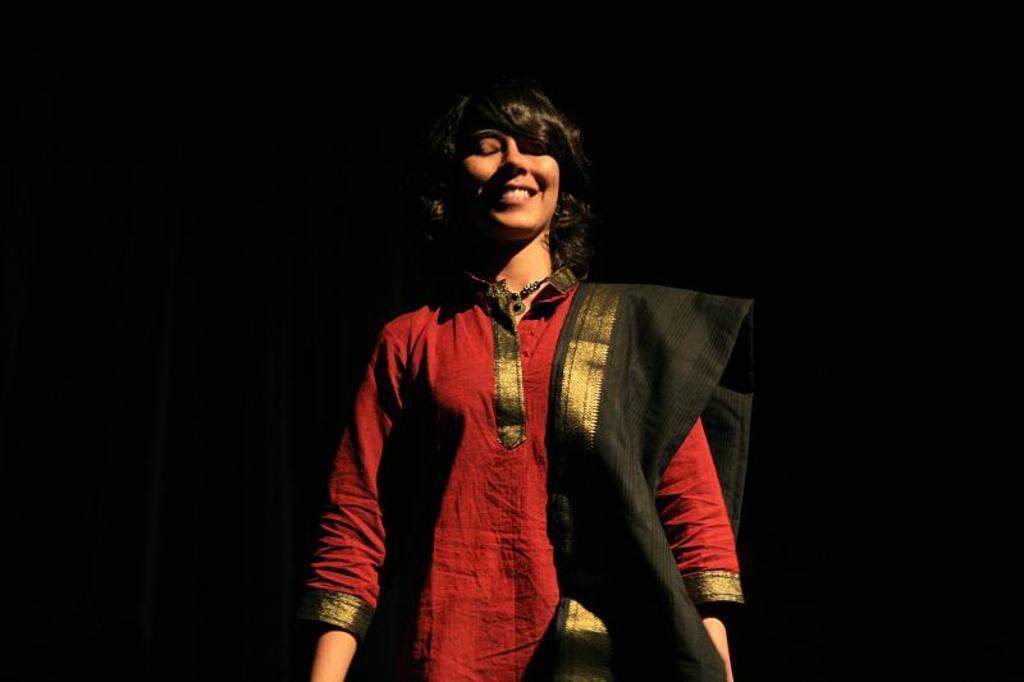Please provide a concise description of this image. In this picture we can see a woman standing and smiling. Background is black in color. 